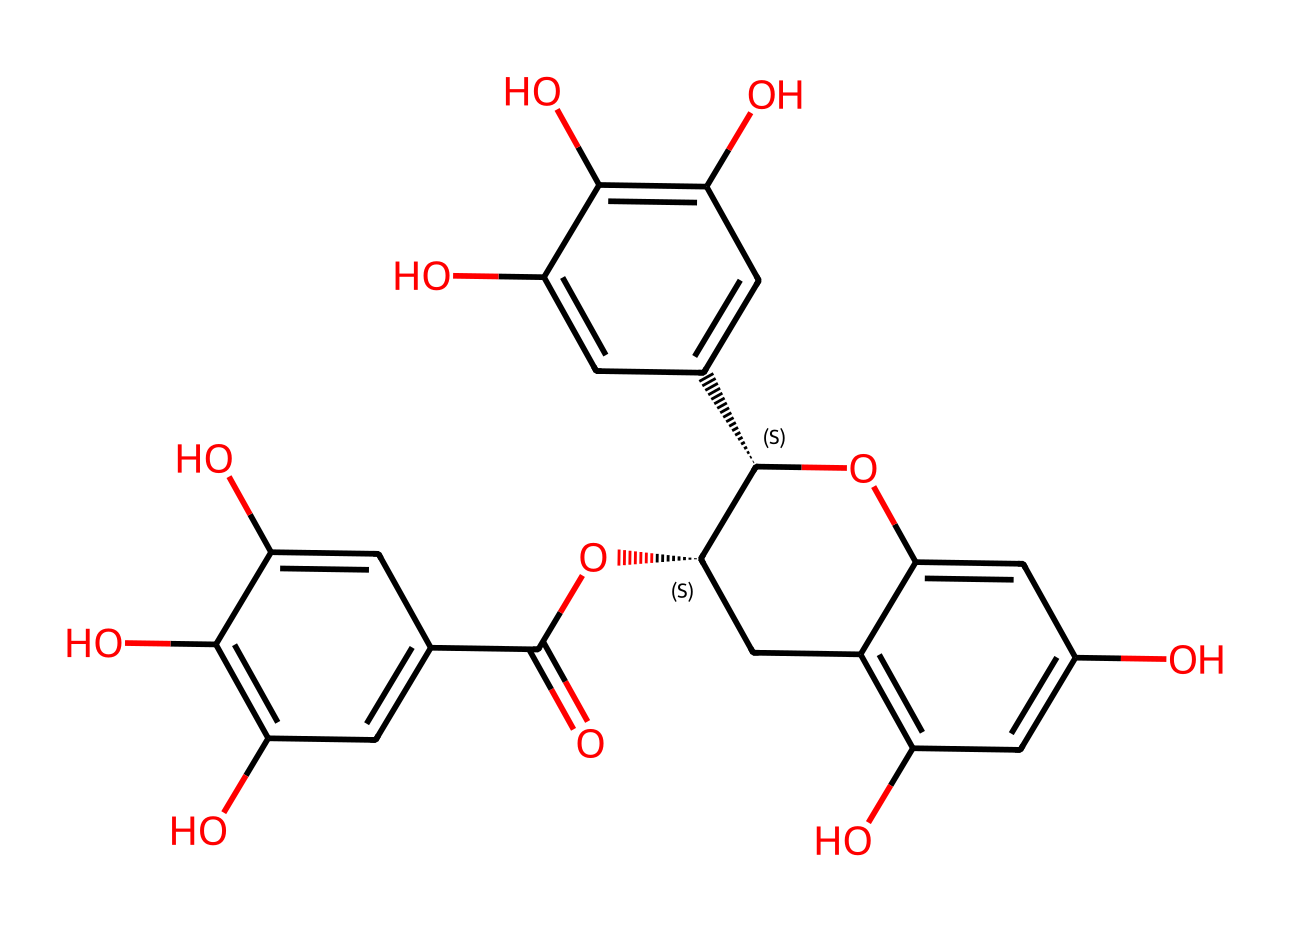What is the molecular formula of EGCG? By analyzing the SMILES representation, we can derive the molecular formula by counting the types and numbers of atoms present. The chemical consists of carbon (C), hydrogen (H), and oxygen (O) atoms. Upon examining the structure, we find it has 21 carbon atoms, 18 hydrogen atoms, and 10 oxygen atoms, leading to the formula C21H18O10.
Answer: C21H18O10 How many hydroxyl groups are present in EGCG? In the structure derived from the SMILES representation, hydroxyl groups (-OH) can be identified by looking for -OH functional groups attached to carbon atoms. Counting these groups reveals that there are 7 hydroxyl groups in the compound.
Answer: 7 What type of compound is EGCG classified as? The structure reveals that it contains multiple phenolic structures due to the presence of hydroxyl groups attached to aromatic rings. This classification as a phenolic compound indicates its potential antioxidant properties and activities.
Answer: polyphenol How many rings are in the EGCG structure? A careful examination of the structure indicates the presence of multiple cyclic (ring) structures. Judging from the arrangement of carbons and the connections, we can identify that there are 5 distinct rings in the entire chemical structure of EGCG.
Answer: 5 Is EGCG a saturated or unsaturated compound? An unsaturated compound is typically characterized by the presence of double bonds between carbon atoms. Analyzing the SMILES representation, we see that there are several double bonds which confirm that EGCG indeed contains unsaturated carbon-carbon linkages.
Answer: unsaturated What is the significance of the aldehyde group's presence in EGCG? Although the provided SMILES does not explicitly denote an aldehyde group, phenolic compounds can exhibit such functional groups which are often vital for their biological activity. However, EGCG specifically has no aldehyde; thus this question emphasizes understanding functional roles within structural contexts.
Answer: no aldehyde 